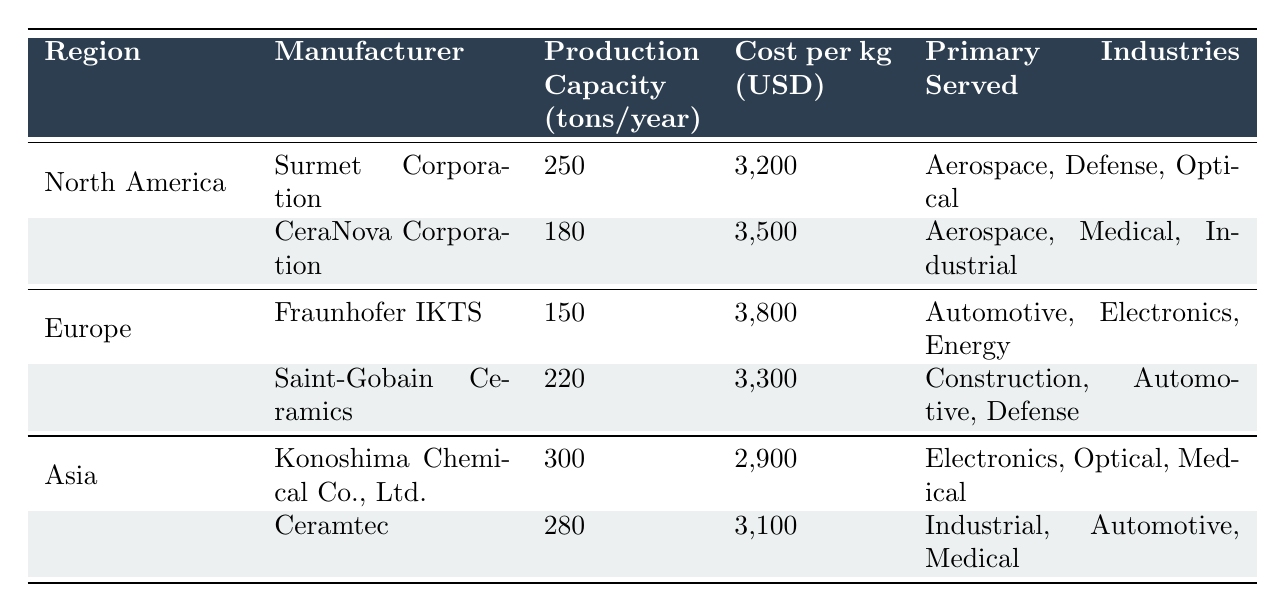What is the production capacity of Surmet Corporation? The data for Surmet Corporation in the North America region shows that its production capacity is listed as 250 tons/year.
Answer: 250 tons/year Which manufacturer has the lowest cost per kg? By comparing the cost per kg of each manufacturer, Konoshima Chemical Co., Ltd. has the lowest cost at 2,900 USD/kg.
Answer: 2,900 USD/kg What is the total production capacity of manufacturers in Europe? The production capacities for Europe are Fraunhofer IKTS at 150 tons/year and Saint-Gobain Ceramics at 220 tons/year. Summing these gives 150 + 220 = 370 tons/year.
Answer: 370 tons/year Does CeraNova Corporation serve the automotive industry? Looking at the primary industries served by CeraNova Corporation, it serves Aerospace, Medical, and Industrial, but not Automotive.
Answer: No What is the average cost per kg for all manufacturers listed in North America? The cost per kg for North American manufacturers is 3,200 USD for Surmet Corporation and 3,500 USD for CeraNova Corporation. The average is (3200 + 3500) / 2 = 3,350 USD/kg.
Answer: 3,350 USD/kg Which region has the highest production capacity from a single manufacturer? In Asia, Konoshima Chemical Co., Ltd. has the highest production capacity of 300 tons/year, which is greater than any manufacturer in other regions.
Answer: Asia What is the total production capacity of all manufacturers? Summing the production capacities gives: North America (250 + 180) + Europe (150 + 220) + Asia (300 + 280) = 1,380 tons/year.
Answer: 1,380 tons/year Which manufacturer has the highest production capacity and what industries do they serve? Konoshima Chemical Co., Ltd. has the highest production capacity of 300 tons/year and serves the Electronics, Optical, and Medical industries.
Answer: Konoshima Chemical Co., Ltd., Electronics, Optical, Medical What's the difference in cost per kg between the most and least expensive manufacturers? The most expensive is Fraunhofer IKTS at 3,800 USD/kg and the least expensive is Konoshima Chemical Co., Ltd. at 2,900 USD/kg. The difference is 3,800 - 2,900 = 900 USD/kg.
Answer: 900 USD/kg Which manufacturers serve both aerospace and medical industries? CeraNova Corporation serves Aerospace and Medical, as well as Konoshima Chemical Co., Ltd. serving Medical. Thus, CeraNova is one, but not both serve both industries.
Answer: CeraNova Corporation and Konoshima Chemical Co., Ltd 